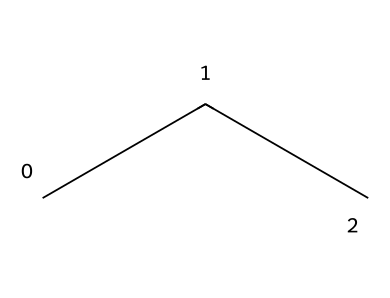How many carbon atoms are in propane? The SMILES representation "CCC" indicates that there are three carbon atoms connected in a chain, as each "C" represents a carbon atom.
Answer: 3 How many hydrogen atoms are in propane? In the structure C3H8, there are eight hydrogen atoms, which corresponds to the formula derived from the general alkane formula (CnH2n+2) for n=3.
Answer: 8 What type of chemical is propane? Propane belongs to the family of hydrocarbons, specifically alkanes, due to its saturated structure and lack of double or triple bonds.
Answer: alkane Is propane a gas at room temperature? Propane is a colorless gas at standard temperature and pressure, which is supported by its physical state under those conditions.
Answer: yes What is the molecular formula for propane? The molecular structure given, when counted, matches the known molecular formula of propane, which is C3H8.
Answer: C3H8 How does propane behave as a refrigerant? As a refrigerant, propane has favorable thermodynamic properties such as low boiling point and high efficiency, making it suitable for portable cooling applications.
Answer: efficient What is one environmental benefit of using propane as a refrigerant? Propane has a low Global Warming Potential (GWP) compared to many traditional refrigerants, indicating less impact on climate change when leaked.
Answer: low GWP 